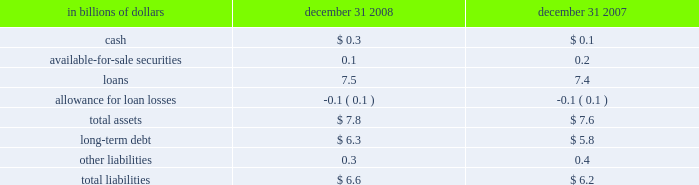On-balance sheet securitizations the company engages in on-balance sheet securitizations .
These are securitizations that do not qualify for sales treatment ; thus , the assets remain on the company 2019s balance sheet .
The table presents the carrying amounts and classification of consolidated assets and liabilities transferred in transactions from the consumer credit card , student loan , mortgage and auto businesses , accounted for as secured borrowings : in billions of dollars december 31 , december 31 .
All assets are restricted from being sold or pledged as collateral .
The cash flows from these assets are the only source used to pay down the associated liabilities , which are non-recourse to the company 2019s general assets .
Citi-administered asset-backed commercial paper conduits the company is active in the asset-backed commercial paper conduit business as administrator of several multi-seller commercial paper conduits , and also as a service provider to single-seller and other commercial paper conduits sponsored by third parties .
The multi-seller commercial paper conduits are designed to provide the company 2019s customers access to low-cost funding in the commercial paper markets .
The conduits purchase assets from or provide financing facilities to customers and are funded by issuing commercial paper to third-party investors .
The conduits generally do not purchase assets originated by the company .
The funding of the conduit is facilitated by the liquidity support and credit enhancements provided by the company and by certain third parties .
As administrator to the conduits , the company is responsible for selecting and structuring of assets purchased or financed by the conduits , making decisions regarding the funding of the conduits , including determining the tenor and other features of the commercial paper issued , monitoring the quality and performance of the conduits 2019 assets , and facilitating the operations and cash flows of the conduits .
In return , the company earns structuring fees from clients for individual transactions and earns an administration fee from the conduit , which is equal to the income from client program and liquidity fees of the conduit after payment of interest costs and other fees .
This administration fee is fairly stable , since most risks and rewards of the underlying assets are passed back to the customers and , once the asset pricing is negotiated , most ongoing income , costs and fees are relatively stable as a percentage of the conduit 2019s size .
The conduits administered by the company do not generally invest in liquid securities that are formally rated by third parties .
The assets are privately negotiated and structured transactions that are designed to be held by the conduit , rather than actively traded and sold .
The yield earned by the conduit on each asset is generally tied to the rate on the commercial paper issued by the conduit , thus passing interest rate risk to the client .
Each asset purchased by the conduit is structured with transaction-specific credit enhancement features provided by the third-party seller , including over- collateralization , cash and excess spread collateral accounts , direct recourse or third-party guarantees .
These credit enhancements are sized with the objective of approximating a credit rating of a or above , based on the company 2019s internal risk ratings .
Substantially all of the funding of the conduits is in the form of short- term commercial paper .
As of december 31 , 2008 , the weighted average life of the commercial paper issued was approximately 37 days .
In addition , the conduits have issued subordinate loss notes and equity with a notional amount of approximately $ 80 million and varying remaining tenors ranging from six months to seven years .
The primary credit enhancement provided to the conduit investors is in the form of transaction-specific credit enhancement described above .
In addition , there are two additional forms of credit enhancement that protect the commercial paper investors from defaulting assets .
First , the subordinate loss notes issued by each conduit absorb any credit losses up to their full notional amount .
It is expected that the subordinate loss notes issued by each conduit are sufficient to absorb a majority of the expected losses from each conduit , thereby making the single investor in the subordinate loss note the primary beneficiary under fin 46 ( r ) .
Second , each conduit has obtained a letter of credit from the company , which is generally 8-10% ( 8-10 % ) of the conduit 2019s assets .
The letters of credit provided by the company total approximately $ 5.8 billion and are included in the company 2019s maximum exposure to loss .
The net result across all multi-seller conduits administered by the company is that , in the event of defaulted assets in excess of the transaction-specific credit enhancement described above , any losses in each conduit are allocated in the following order : 2022 subordinate loss note holders 2022 the company 2022 the commercial paper investors the company , along with third parties , also provides the conduits with two forms of liquidity agreements that are used to provide funding to the conduits in the event of a market disruption , among other events .
Each asset of the conduit is supported by a transaction-specific liquidity facility in the form of an asset purchase agreement ( apa ) .
Under the apa , the company has agreed to purchase non-defaulted eligible receivables from the conduit at par .
Any assets purchased under the apa are subject to increased pricing .
The apa is not designed to provide credit support to the conduit , as it generally does not permit the purchase of defaulted or impaired assets and generally reprices the assets purchased to consider potential increased credit risk .
The apa covers all assets in the conduits and is considered in the company 2019s maximum exposure to loss .
In addition , the company provides the conduits with program-wide liquidity in the form of short-term lending commitments .
Under these commitments , the company has agreed to lend to the conduits in the event of a short-term disruption in the commercial paper market , subject to specified conditions .
The total notional exposure under the program-wide liquidity agreement is $ 11.3 billion and is considered in the company 2019s maximum exposure to loss .
The company receives fees for providing both types of liquidity agreement and considers these fees to be on fair market terms. .
What was the percentage increase in the total assets from 2007 to 2008? 
Computations: ((7.8 - 7.6) / 7.6)
Answer: 0.02632. 